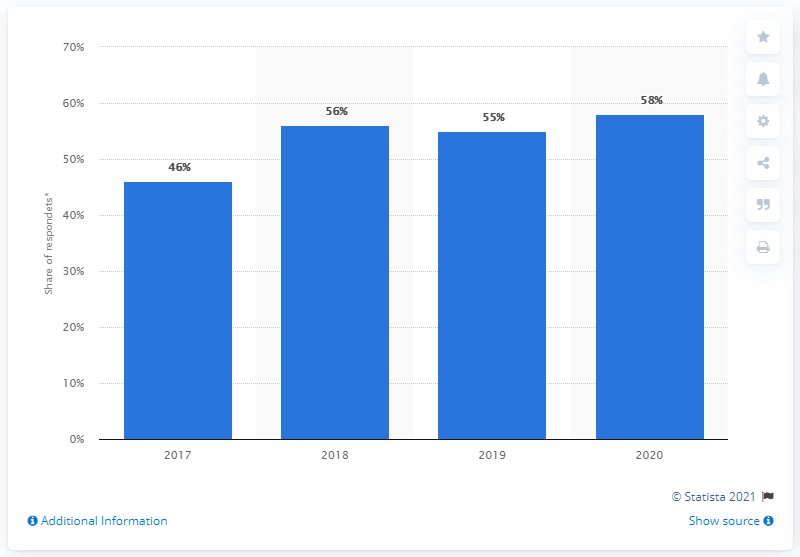Outline some significant characteristics in this image. In 2017, the percentage of people who trusted the President increased. 